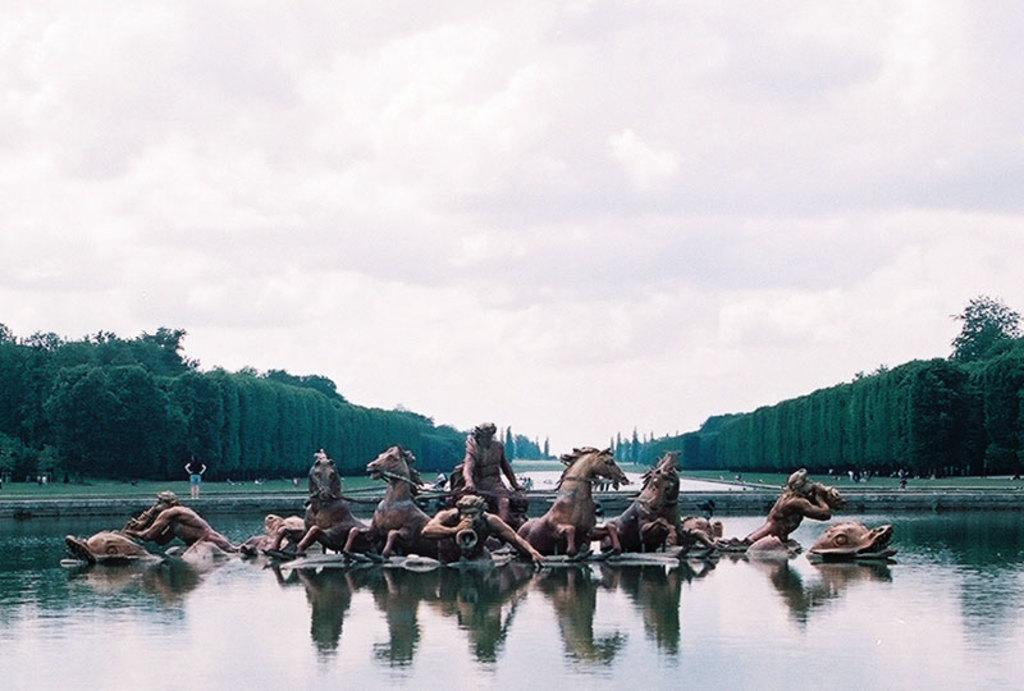What is on the water surface in the image? There are sculptures on the water surface in the image. What type of vegetation can be seen behind the water surface? There are trees visible behind the water surface. What else can be seen behind the water surface? There is grass visible behind the water surface. What type of pin can be seen holding the sculptures together in the image? There is no pin visible in the image; the sculptures are on the water surface. What paste is used to create the sculptures in the image? There is no mention of any paste being used to create the sculptures in the image. 